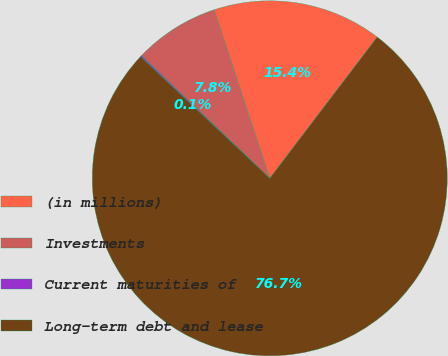<chart> <loc_0><loc_0><loc_500><loc_500><pie_chart><fcel>(in millions)<fcel>Investments<fcel>Current maturities of<fcel>Long-term debt and lease<nl><fcel>15.43%<fcel>7.77%<fcel>0.12%<fcel>76.68%<nl></chart> 